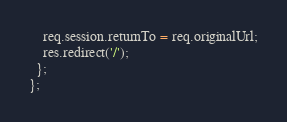<code> <loc_0><loc_0><loc_500><loc_500><_JavaScript_>    req.session.returnTo = req.originalUrl;
    res.redirect('/');
  };
};
</code> 